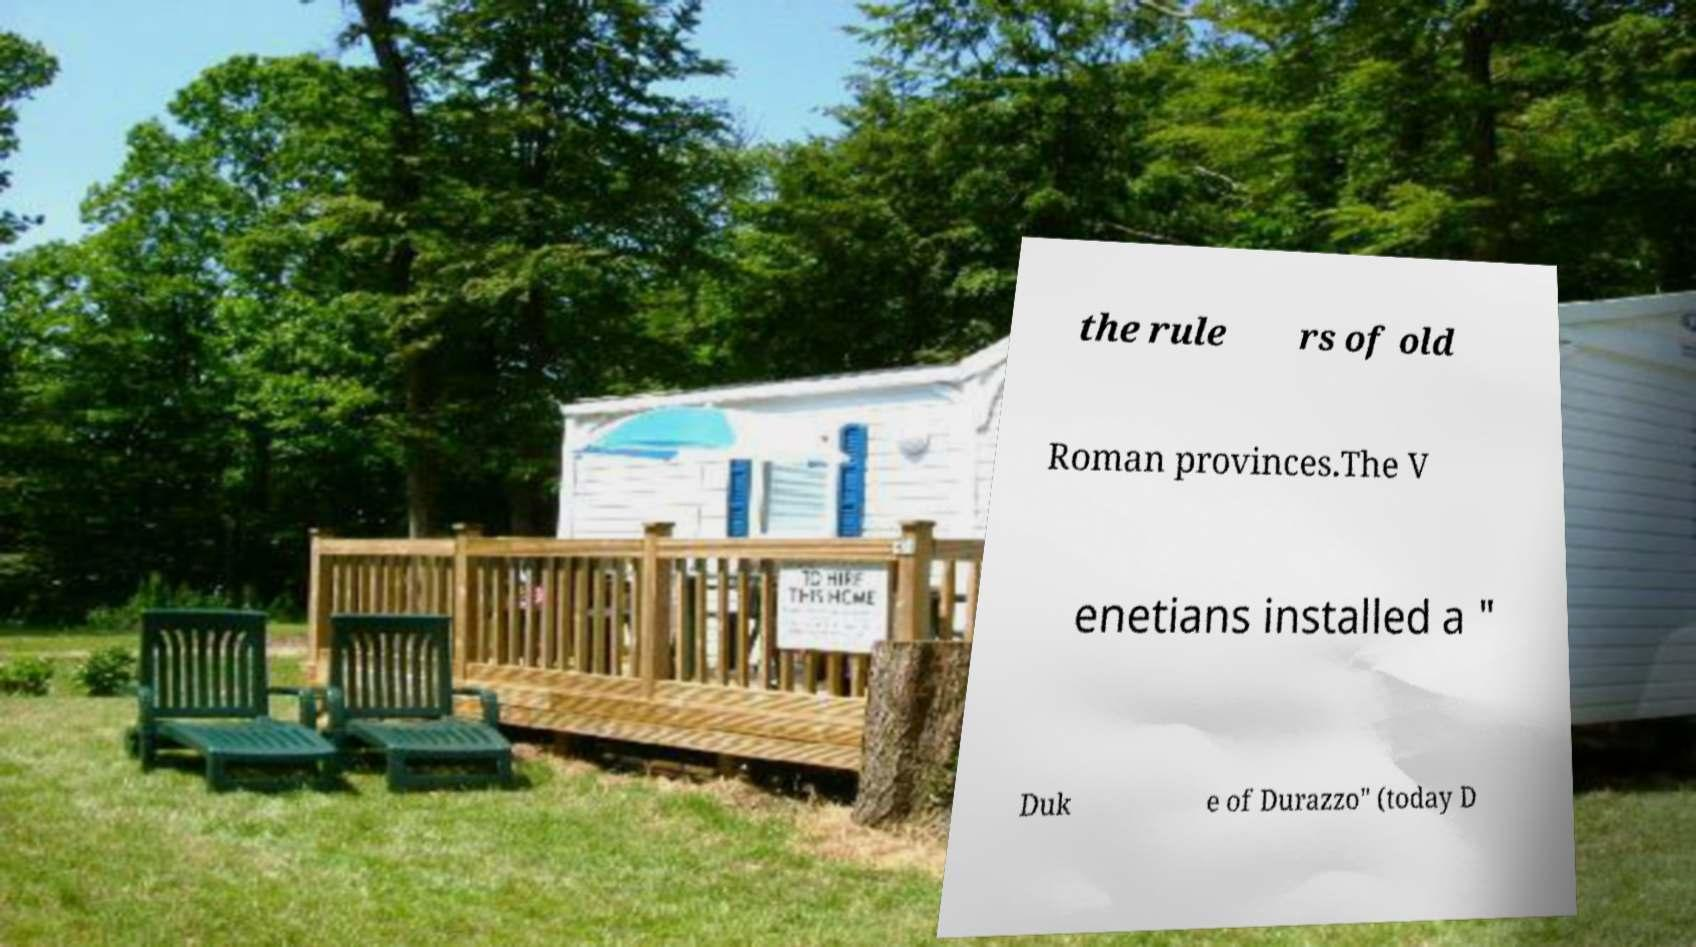Could you extract and type out the text from this image? the rule rs of old Roman provinces.The V enetians installed a " Duk e of Durazzo" (today D 